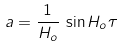Convert formula to latex. <formula><loc_0><loc_0><loc_500><loc_500>a = \frac { 1 } { H _ { o } } \, \sin H _ { o } \tau</formula> 